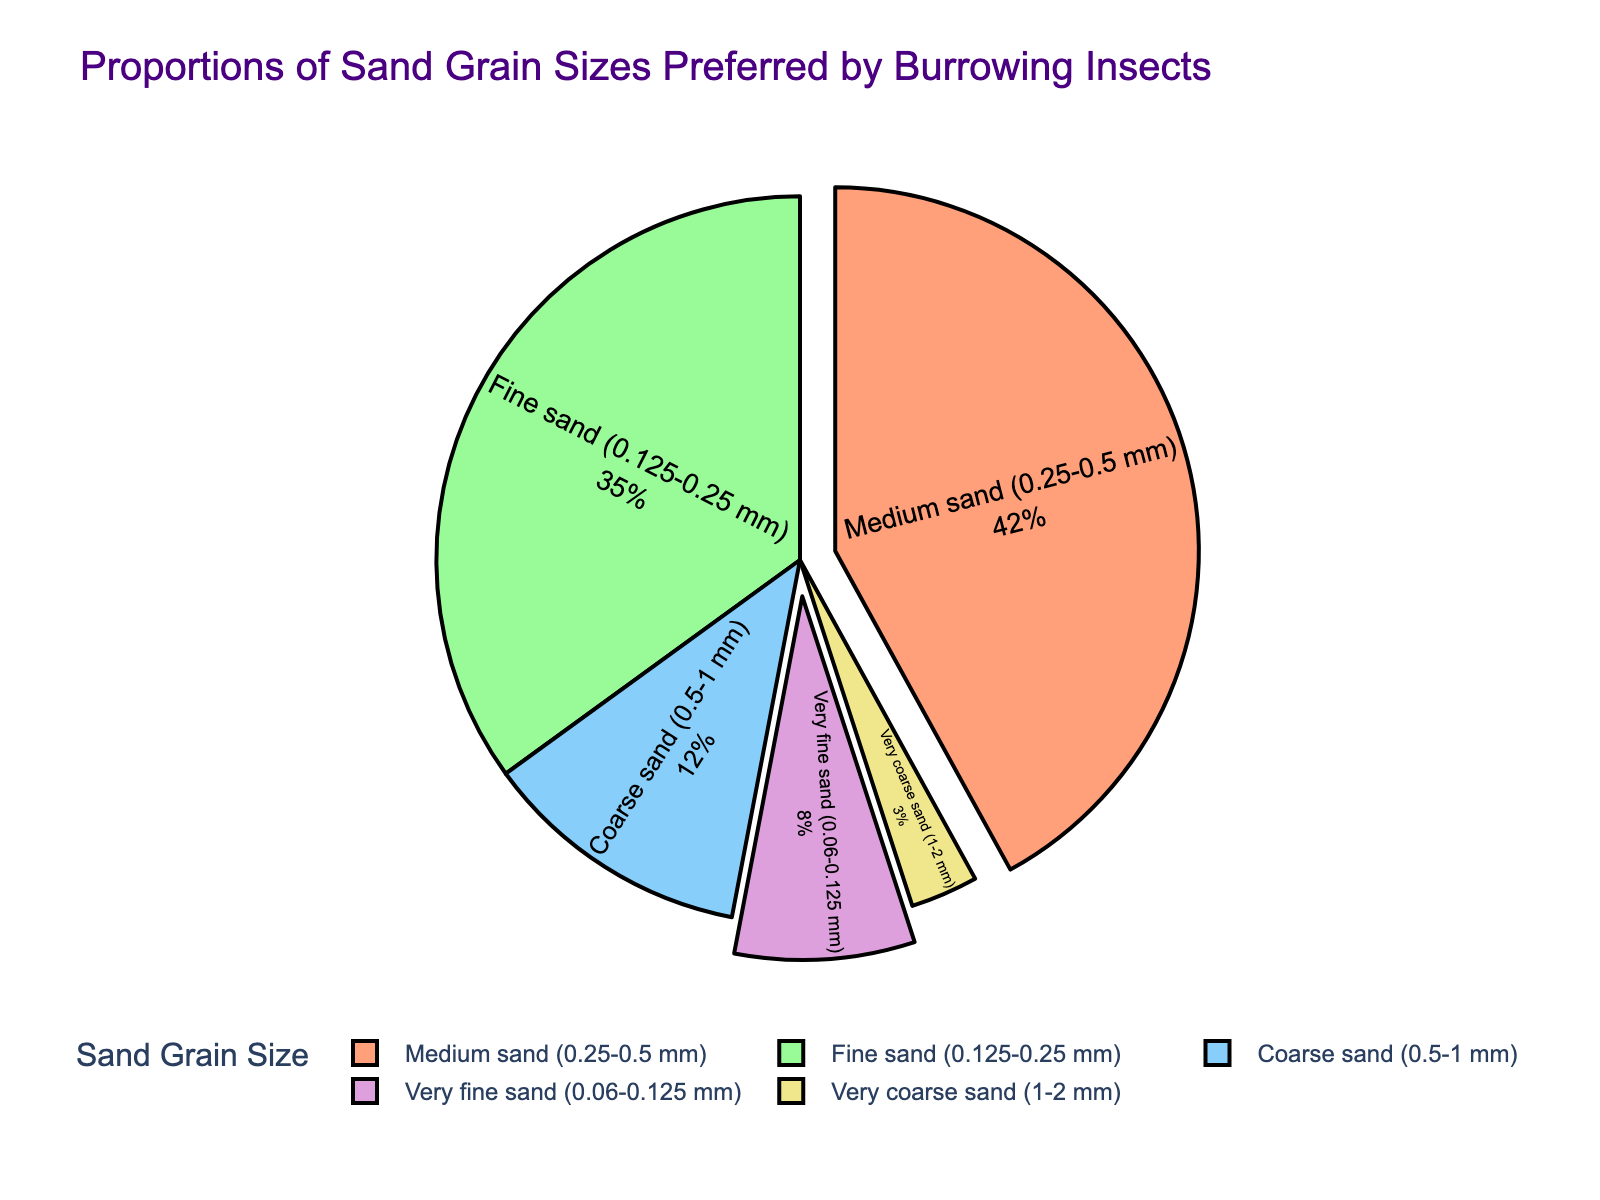What is the most preferred sand grain size by burrowing insects? The pie chart displays various percentages for different sand grain sizes. The segment labeled 'Medium sand (0.25-0.5 mm)' holds the highest percentage at 42%, indicating it is the most preferred.
Answer: Medium sand (0.25-0.5 mm) Which sand grain size is least preferred by burrowing insects? A quick look at the pie chart shows that the segment labeled 'Very coarse sand (1-2 mm)' has the smallest percentage at 3%, indicating it's the least preferred.
Answer: Very coarse sand (1-2 mm) What is the combined percentage of insects that prefer sand with grain sizes less than 0.25 mm? The grain sizes less than 0.25 mm are 'Very fine sand (0.06-0.125 mm)' and 'Fine sand (0.125-0.25 mm)' with percentages of 8% and 35%, respectively. Adding these: \( 8\% + 35\% = 43\% \).
Answer: 43% How much more preferred is the 'Medium sand' compared to 'Very coarse sand'? The 'Medium sand (0.25-0.5 mm)' has 42%, and the 'Very coarse sand (1-2 mm)' has 3%. Subtracting the two: \( 42\% - 3\% = 39\% \).
Answer: 39% Is the preference for 'Coarse sand' less than the preference for 'Fine sand'? Looking at the pie chart, 'Coarse sand (0.5-1 mm)' is at 12%, and 'Fine sand (0.125-0.25 mm)' is at 35%. Clearly, 12% is less than 35%.
Answer: Yes Which sand grain sizes make up more than a third of the pie? One third of 100% is approximately 33.33%. The 'Fine sand (0.125-0.25 mm)' is at 35%, and 'Medium sand (0.25-0.5 mm)' is at 42%, both of which are greater than 33.33%.
Answer: Fine sand, Medium sand What are the colors associated with the largest and smallest segments? From visual inspection, the largest segment is 'Medium sand (0.25-0.5 mm)' which is colored blue, and the smallest segment is 'Very coarse sand (1-2 mm)' which is colored yellow.
Answer: Blue, Yellow By how much does the preference for 'Medium sand' exceed the combined preference for both 'Very fine sand' and 'Very coarse sand'? 'Medium sand (0.25-0.5 mm)' is 42%. 'Very fine sand (0.06-0.125 mm)' is 8%, and 'Very coarse sand (1-2 mm)' is 3%. Combined preference for both is \( 8\% + 3\% = 11\% \). Exceeding value: \( 42\% - 11\% = 31\% \).
Answer: 31% What fraction of the pie chart is occupied by the preferred grain sizes of burrowing insects? The preferred grain sizes as indicated by the chart are all segments in percentages. Summing these: \( 8\% + 35\% + 42\% + 12\% + 3\% = 100\% \).
Answer: 1 (or 100%) Which two sand grain sizes together make up the majority of the pie? A majority is anything over 50%. Combining 'Fine sand (0.125-0.25 mm)' at 35% and 'Medium sand (0.25-0.5 mm)' at 42% results in \( 35\% + 42\% = 77\% \), which is a majority.
Answer: Fine sand, Medium sand 